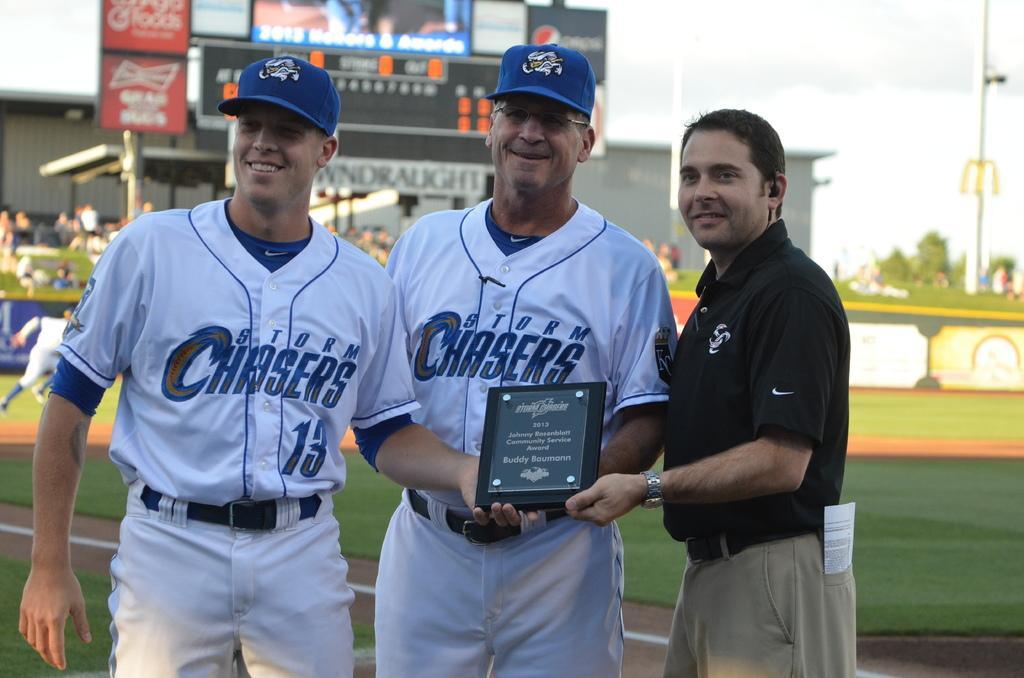In one or two sentences, can you explain what this image depicts? In this image we can see three persons standing and holding an object. Behind the persons we can see a group of persons, hoarding and a building. On the right side of the image we can see a pillar, wall and grass. At the top we can see the sky. 